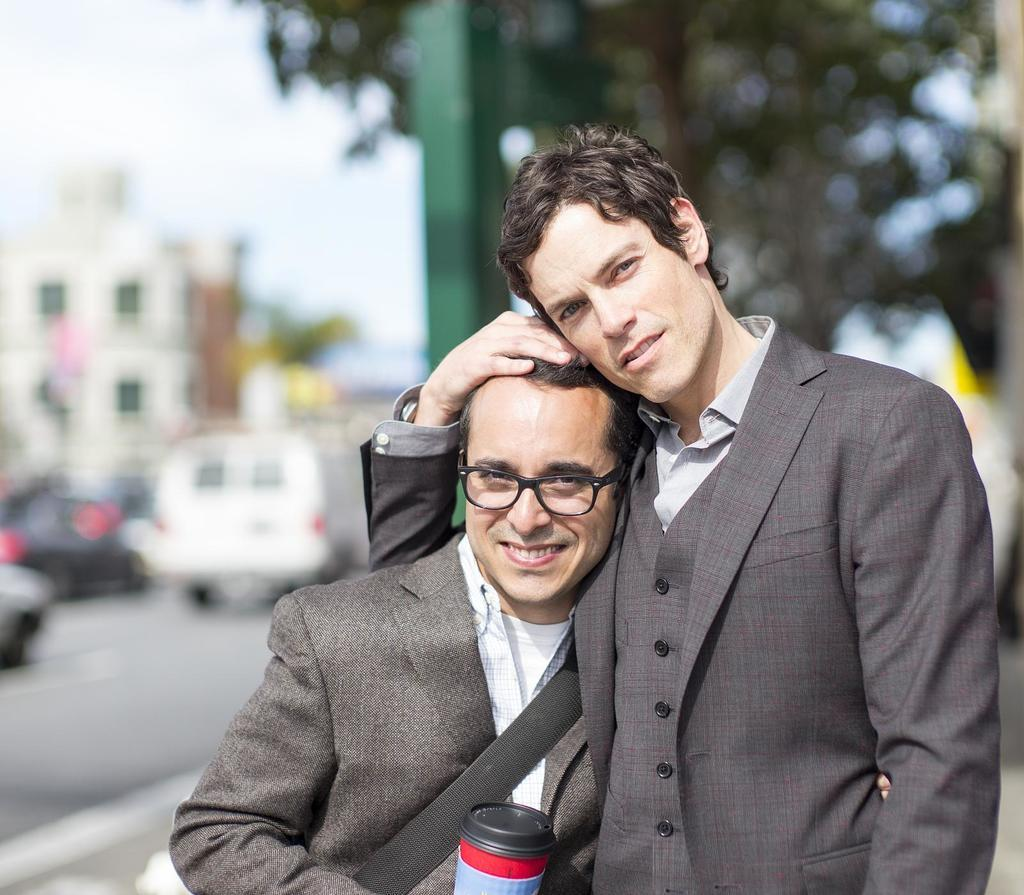How many people are in the image? There are people in the image, but the exact number is not specified. Which person is highlighted in the image? One person is highlighted in the image. What can be observed about the background of the image? The background of the image is blurred, and trees, buildings, poles, vehicles, and a road are visible. What type of butter is being used by the person in the image? There is no butter present in the image. Is the person in the image a crook? The facts provided do not give any information about the person's character or occupation, so it cannot be determined if they are a crook. 